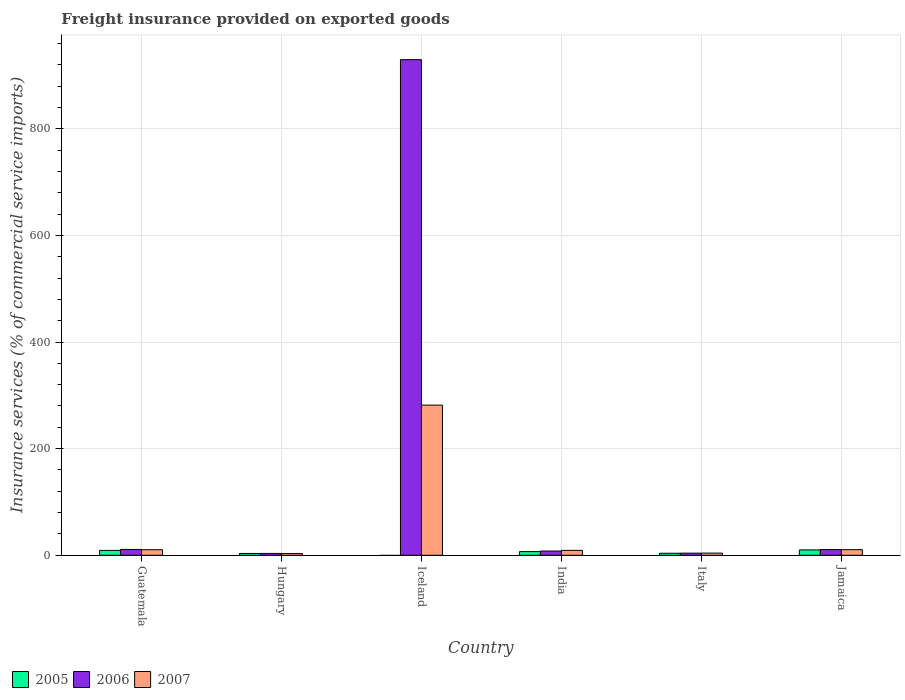How many different coloured bars are there?
Provide a short and direct response. 3. How many groups of bars are there?
Offer a very short reply. 6. What is the label of the 1st group of bars from the left?
Offer a terse response. Guatemala. What is the freight insurance provided on exported goods in 2005 in Jamaica?
Offer a very short reply. 10.03. Across all countries, what is the maximum freight insurance provided on exported goods in 2005?
Your answer should be very brief. 10.03. Across all countries, what is the minimum freight insurance provided on exported goods in 2007?
Offer a terse response. 3.16. In which country was the freight insurance provided on exported goods in 2005 maximum?
Make the answer very short. Jamaica. What is the total freight insurance provided on exported goods in 2007 in the graph?
Offer a terse response. 319.09. What is the difference between the freight insurance provided on exported goods in 2006 in Iceland and that in India?
Provide a short and direct response. 921.63. What is the difference between the freight insurance provided on exported goods in 2007 in Guatemala and the freight insurance provided on exported goods in 2005 in Hungary?
Offer a very short reply. 7. What is the average freight insurance provided on exported goods in 2007 per country?
Keep it short and to the point. 53.18. What is the difference between the freight insurance provided on exported goods of/in 2006 and freight insurance provided on exported goods of/in 2007 in Jamaica?
Offer a very short reply. 0.15. In how many countries, is the freight insurance provided on exported goods in 2007 greater than 440 %?
Provide a succinct answer. 0. What is the ratio of the freight insurance provided on exported goods in 2007 in Guatemala to that in Italy?
Your response must be concise. 2.56. Is the freight insurance provided on exported goods in 2007 in Hungary less than that in Jamaica?
Your response must be concise. Yes. What is the difference between the highest and the second highest freight insurance provided on exported goods in 2006?
Offer a terse response. 918.68. What is the difference between the highest and the lowest freight insurance provided on exported goods in 2005?
Offer a very short reply. 10.03. In how many countries, is the freight insurance provided on exported goods in 2006 greater than the average freight insurance provided on exported goods in 2006 taken over all countries?
Offer a very short reply. 1. Is the sum of the freight insurance provided on exported goods in 2007 in India and Jamaica greater than the maximum freight insurance provided on exported goods in 2006 across all countries?
Offer a terse response. No. Are all the bars in the graph horizontal?
Make the answer very short. No. What is the difference between two consecutive major ticks on the Y-axis?
Offer a very short reply. 200. Are the values on the major ticks of Y-axis written in scientific E-notation?
Ensure brevity in your answer.  No. Does the graph contain any zero values?
Your answer should be compact. Yes. Where does the legend appear in the graph?
Offer a very short reply. Bottom left. How many legend labels are there?
Provide a succinct answer. 3. What is the title of the graph?
Give a very brief answer. Freight insurance provided on exported goods. What is the label or title of the Y-axis?
Ensure brevity in your answer.  Insurance services (% of commercial service imports). What is the Insurance services (% of commercial service imports) in 2005 in Guatemala?
Provide a succinct answer. 9.14. What is the Insurance services (% of commercial service imports) in 2006 in Guatemala?
Your answer should be very brief. 10.92. What is the Insurance services (% of commercial service imports) of 2007 in Guatemala?
Keep it short and to the point. 10.41. What is the Insurance services (% of commercial service imports) of 2005 in Hungary?
Ensure brevity in your answer.  3.41. What is the Insurance services (% of commercial service imports) in 2006 in Hungary?
Make the answer very short. 3.46. What is the Insurance services (% of commercial service imports) in 2007 in Hungary?
Ensure brevity in your answer.  3.16. What is the Insurance services (% of commercial service imports) of 2005 in Iceland?
Your response must be concise. 0. What is the Insurance services (% of commercial service imports) in 2006 in Iceland?
Provide a short and direct response. 929.6. What is the Insurance services (% of commercial service imports) in 2007 in Iceland?
Offer a very short reply. 281.68. What is the Insurance services (% of commercial service imports) of 2005 in India?
Ensure brevity in your answer.  6.85. What is the Insurance services (% of commercial service imports) in 2006 in India?
Give a very brief answer. 7.96. What is the Insurance services (% of commercial service imports) of 2007 in India?
Give a very brief answer. 9.21. What is the Insurance services (% of commercial service imports) of 2005 in Italy?
Offer a very short reply. 3.79. What is the Insurance services (% of commercial service imports) in 2006 in Italy?
Your answer should be compact. 3.97. What is the Insurance services (% of commercial service imports) of 2007 in Italy?
Make the answer very short. 4.07. What is the Insurance services (% of commercial service imports) in 2005 in Jamaica?
Offer a very short reply. 10.03. What is the Insurance services (% of commercial service imports) in 2006 in Jamaica?
Provide a short and direct response. 10.71. What is the Insurance services (% of commercial service imports) in 2007 in Jamaica?
Offer a terse response. 10.56. Across all countries, what is the maximum Insurance services (% of commercial service imports) in 2005?
Your response must be concise. 10.03. Across all countries, what is the maximum Insurance services (% of commercial service imports) in 2006?
Ensure brevity in your answer.  929.6. Across all countries, what is the maximum Insurance services (% of commercial service imports) of 2007?
Your answer should be compact. 281.68. Across all countries, what is the minimum Insurance services (% of commercial service imports) in 2005?
Make the answer very short. 0. Across all countries, what is the minimum Insurance services (% of commercial service imports) in 2006?
Provide a succinct answer. 3.46. Across all countries, what is the minimum Insurance services (% of commercial service imports) of 2007?
Your response must be concise. 3.16. What is the total Insurance services (% of commercial service imports) in 2005 in the graph?
Provide a succinct answer. 33.22. What is the total Insurance services (% of commercial service imports) of 2006 in the graph?
Your response must be concise. 966.62. What is the total Insurance services (% of commercial service imports) in 2007 in the graph?
Give a very brief answer. 319.09. What is the difference between the Insurance services (% of commercial service imports) of 2005 in Guatemala and that in Hungary?
Your response must be concise. 5.73. What is the difference between the Insurance services (% of commercial service imports) of 2006 in Guatemala and that in Hungary?
Offer a terse response. 7.46. What is the difference between the Insurance services (% of commercial service imports) in 2007 in Guatemala and that in Hungary?
Give a very brief answer. 7.25. What is the difference between the Insurance services (% of commercial service imports) in 2006 in Guatemala and that in Iceland?
Provide a short and direct response. -918.68. What is the difference between the Insurance services (% of commercial service imports) in 2007 in Guatemala and that in Iceland?
Offer a very short reply. -271.27. What is the difference between the Insurance services (% of commercial service imports) of 2005 in Guatemala and that in India?
Your answer should be compact. 2.29. What is the difference between the Insurance services (% of commercial service imports) in 2006 in Guatemala and that in India?
Offer a very short reply. 2.96. What is the difference between the Insurance services (% of commercial service imports) in 2007 in Guatemala and that in India?
Give a very brief answer. 1.2. What is the difference between the Insurance services (% of commercial service imports) in 2005 in Guatemala and that in Italy?
Keep it short and to the point. 5.35. What is the difference between the Insurance services (% of commercial service imports) in 2006 in Guatemala and that in Italy?
Offer a terse response. 6.95. What is the difference between the Insurance services (% of commercial service imports) of 2007 in Guatemala and that in Italy?
Ensure brevity in your answer.  6.34. What is the difference between the Insurance services (% of commercial service imports) of 2005 in Guatemala and that in Jamaica?
Make the answer very short. -0.89. What is the difference between the Insurance services (% of commercial service imports) in 2006 in Guatemala and that in Jamaica?
Your answer should be compact. 0.21. What is the difference between the Insurance services (% of commercial service imports) of 2007 in Guatemala and that in Jamaica?
Provide a succinct answer. -0.15. What is the difference between the Insurance services (% of commercial service imports) of 2006 in Hungary and that in Iceland?
Provide a short and direct response. -926.14. What is the difference between the Insurance services (% of commercial service imports) in 2007 in Hungary and that in Iceland?
Keep it short and to the point. -278.52. What is the difference between the Insurance services (% of commercial service imports) in 2005 in Hungary and that in India?
Ensure brevity in your answer.  -3.44. What is the difference between the Insurance services (% of commercial service imports) in 2006 in Hungary and that in India?
Make the answer very short. -4.5. What is the difference between the Insurance services (% of commercial service imports) of 2007 in Hungary and that in India?
Ensure brevity in your answer.  -6.05. What is the difference between the Insurance services (% of commercial service imports) of 2005 in Hungary and that in Italy?
Your answer should be very brief. -0.37. What is the difference between the Insurance services (% of commercial service imports) in 2006 in Hungary and that in Italy?
Your response must be concise. -0.51. What is the difference between the Insurance services (% of commercial service imports) of 2007 in Hungary and that in Italy?
Your answer should be very brief. -0.92. What is the difference between the Insurance services (% of commercial service imports) in 2005 in Hungary and that in Jamaica?
Make the answer very short. -6.61. What is the difference between the Insurance services (% of commercial service imports) in 2006 in Hungary and that in Jamaica?
Ensure brevity in your answer.  -7.25. What is the difference between the Insurance services (% of commercial service imports) in 2007 in Hungary and that in Jamaica?
Your response must be concise. -7.4. What is the difference between the Insurance services (% of commercial service imports) in 2006 in Iceland and that in India?
Provide a succinct answer. 921.63. What is the difference between the Insurance services (% of commercial service imports) of 2007 in Iceland and that in India?
Keep it short and to the point. 272.46. What is the difference between the Insurance services (% of commercial service imports) of 2006 in Iceland and that in Italy?
Offer a very short reply. 925.62. What is the difference between the Insurance services (% of commercial service imports) in 2007 in Iceland and that in Italy?
Offer a very short reply. 277.6. What is the difference between the Insurance services (% of commercial service imports) in 2006 in Iceland and that in Jamaica?
Give a very brief answer. 918.89. What is the difference between the Insurance services (% of commercial service imports) of 2007 in Iceland and that in Jamaica?
Ensure brevity in your answer.  271.12. What is the difference between the Insurance services (% of commercial service imports) of 2005 in India and that in Italy?
Your response must be concise. 3.06. What is the difference between the Insurance services (% of commercial service imports) in 2006 in India and that in Italy?
Your answer should be very brief. 3.99. What is the difference between the Insurance services (% of commercial service imports) of 2007 in India and that in Italy?
Your response must be concise. 5.14. What is the difference between the Insurance services (% of commercial service imports) of 2005 in India and that in Jamaica?
Keep it short and to the point. -3.18. What is the difference between the Insurance services (% of commercial service imports) in 2006 in India and that in Jamaica?
Offer a terse response. -2.75. What is the difference between the Insurance services (% of commercial service imports) of 2007 in India and that in Jamaica?
Give a very brief answer. -1.35. What is the difference between the Insurance services (% of commercial service imports) in 2005 in Italy and that in Jamaica?
Your response must be concise. -6.24. What is the difference between the Insurance services (% of commercial service imports) of 2006 in Italy and that in Jamaica?
Ensure brevity in your answer.  -6.74. What is the difference between the Insurance services (% of commercial service imports) of 2007 in Italy and that in Jamaica?
Your response must be concise. -6.49. What is the difference between the Insurance services (% of commercial service imports) of 2005 in Guatemala and the Insurance services (% of commercial service imports) of 2006 in Hungary?
Make the answer very short. 5.68. What is the difference between the Insurance services (% of commercial service imports) of 2005 in Guatemala and the Insurance services (% of commercial service imports) of 2007 in Hungary?
Provide a short and direct response. 5.98. What is the difference between the Insurance services (% of commercial service imports) of 2006 in Guatemala and the Insurance services (% of commercial service imports) of 2007 in Hungary?
Your response must be concise. 7.76. What is the difference between the Insurance services (% of commercial service imports) of 2005 in Guatemala and the Insurance services (% of commercial service imports) of 2006 in Iceland?
Your answer should be compact. -920.46. What is the difference between the Insurance services (% of commercial service imports) of 2005 in Guatemala and the Insurance services (% of commercial service imports) of 2007 in Iceland?
Provide a succinct answer. -272.54. What is the difference between the Insurance services (% of commercial service imports) of 2006 in Guatemala and the Insurance services (% of commercial service imports) of 2007 in Iceland?
Give a very brief answer. -270.76. What is the difference between the Insurance services (% of commercial service imports) in 2005 in Guatemala and the Insurance services (% of commercial service imports) in 2006 in India?
Offer a terse response. 1.18. What is the difference between the Insurance services (% of commercial service imports) of 2005 in Guatemala and the Insurance services (% of commercial service imports) of 2007 in India?
Your answer should be compact. -0.07. What is the difference between the Insurance services (% of commercial service imports) in 2006 in Guatemala and the Insurance services (% of commercial service imports) in 2007 in India?
Make the answer very short. 1.71. What is the difference between the Insurance services (% of commercial service imports) in 2005 in Guatemala and the Insurance services (% of commercial service imports) in 2006 in Italy?
Make the answer very short. 5.17. What is the difference between the Insurance services (% of commercial service imports) in 2005 in Guatemala and the Insurance services (% of commercial service imports) in 2007 in Italy?
Offer a terse response. 5.07. What is the difference between the Insurance services (% of commercial service imports) in 2006 in Guatemala and the Insurance services (% of commercial service imports) in 2007 in Italy?
Make the answer very short. 6.85. What is the difference between the Insurance services (% of commercial service imports) of 2005 in Guatemala and the Insurance services (% of commercial service imports) of 2006 in Jamaica?
Provide a succinct answer. -1.57. What is the difference between the Insurance services (% of commercial service imports) of 2005 in Guatemala and the Insurance services (% of commercial service imports) of 2007 in Jamaica?
Offer a very short reply. -1.42. What is the difference between the Insurance services (% of commercial service imports) in 2006 in Guatemala and the Insurance services (% of commercial service imports) in 2007 in Jamaica?
Your response must be concise. 0.36. What is the difference between the Insurance services (% of commercial service imports) in 2005 in Hungary and the Insurance services (% of commercial service imports) in 2006 in Iceland?
Provide a succinct answer. -926.18. What is the difference between the Insurance services (% of commercial service imports) in 2005 in Hungary and the Insurance services (% of commercial service imports) in 2007 in Iceland?
Ensure brevity in your answer.  -278.26. What is the difference between the Insurance services (% of commercial service imports) in 2006 in Hungary and the Insurance services (% of commercial service imports) in 2007 in Iceland?
Ensure brevity in your answer.  -278.22. What is the difference between the Insurance services (% of commercial service imports) of 2005 in Hungary and the Insurance services (% of commercial service imports) of 2006 in India?
Offer a very short reply. -4.55. What is the difference between the Insurance services (% of commercial service imports) in 2005 in Hungary and the Insurance services (% of commercial service imports) in 2007 in India?
Ensure brevity in your answer.  -5.8. What is the difference between the Insurance services (% of commercial service imports) in 2006 in Hungary and the Insurance services (% of commercial service imports) in 2007 in India?
Offer a very short reply. -5.75. What is the difference between the Insurance services (% of commercial service imports) of 2005 in Hungary and the Insurance services (% of commercial service imports) of 2006 in Italy?
Give a very brief answer. -0.56. What is the difference between the Insurance services (% of commercial service imports) of 2005 in Hungary and the Insurance services (% of commercial service imports) of 2007 in Italy?
Offer a very short reply. -0.66. What is the difference between the Insurance services (% of commercial service imports) of 2006 in Hungary and the Insurance services (% of commercial service imports) of 2007 in Italy?
Your response must be concise. -0.61. What is the difference between the Insurance services (% of commercial service imports) of 2005 in Hungary and the Insurance services (% of commercial service imports) of 2006 in Jamaica?
Keep it short and to the point. -7.3. What is the difference between the Insurance services (% of commercial service imports) of 2005 in Hungary and the Insurance services (% of commercial service imports) of 2007 in Jamaica?
Provide a succinct answer. -7.15. What is the difference between the Insurance services (% of commercial service imports) of 2006 in Hungary and the Insurance services (% of commercial service imports) of 2007 in Jamaica?
Give a very brief answer. -7.1. What is the difference between the Insurance services (% of commercial service imports) of 2006 in Iceland and the Insurance services (% of commercial service imports) of 2007 in India?
Keep it short and to the point. 920.38. What is the difference between the Insurance services (% of commercial service imports) in 2006 in Iceland and the Insurance services (% of commercial service imports) in 2007 in Italy?
Provide a short and direct response. 925.52. What is the difference between the Insurance services (% of commercial service imports) of 2006 in Iceland and the Insurance services (% of commercial service imports) of 2007 in Jamaica?
Your answer should be compact. 919.04. What is the difference between the Insurance services (% of commercial service imports) in 2005 in India and the Insurance services (% of commercial service imports) in 2006 in Italy?
Make the answer very short. 2.88. What is the difference between the Insurance services (% of commercial service imports) in 2005 in India and the Insurance services (% of commercial service imports) in 2007 in Italy?
Offer a terse response. 2.78. What is the difference between the Insurance services (% of commercial service imports) in 2006 in India and the Insurance services (% of commercial service imports) in 2007 in Italy?
Keep it short and to the point. 3.89. What is the difference between the Insurance services (% of commercial service imports) of 2005 in India and the Insurance services (% of commercial service imports) of 2006 in Jamaica?
Make the answer very short. -3.86. What is the difference between the Insurance services (% of commercial service imports) of 2005 in India and the Insurance services (% of commercial service imports) of 2007 in Jamaica?
Keep it short and to the point. -3.71. What is the difference between the Insurance services (% of commercial service imports) in 2006 in India and the Insurance services (% of commercial service imports) in 2007 in Jamaica?
Your response must be concise. -2.6. What is the difference between the Insurance services (% of commercial service imports) in 2005 in Italy and the Insurance services (% of commercial service imports) in 2006 in Jamaica?
Offer a very short reply. -6.92. What is the difference between the Insurance services (% of commercial service imports) of 2005 in Italy and the Insurance services (% of commercial service imports) of 2007 in Jamaica?
Make the answer very short. -6.77. What is the difference between the Insurance services (% of commercial service imports) of 2006 in Italy and the Insurance services (% of commercial service imports) of 2007 in Jamaica?
Offer a terse response. -6.59. What is the average Insurance services (% of commercial service imports) of 2005 per country?
Your response must be concise. 5.54. What is the average Insurance services (% of commercial service imports) in 2006 per country?
Offer a very short reply. 161.1. What is the average Insurance services (% of commercial service imports) in 2007 per country?
Provide a short and direct response. 53.18. What is the difference between the Insurance services (% of commercial service imports) of 2005 and Insurance services (% of commercial service imports) of 2006 in Guatemala?
Your response must be concise. -1.78. What is the difference between the Insurance services (% of commercial service imports) of 2005 and Insurance services (% of commercial service imports) of 2007 in Guatemala?
Give a very brief answer. -1.27. What is the difference between the Insurance services (% of commercial service imports) of 2006 and Insurance services (% of commercial service imports) of 2007 in Guatemala?
Offer a very short reply. 0.51. What is the difference between the Insurance services (% of commercial service imports) in 2005 and Insurance services (% of commercial service imports) in 2006 in Hungary?
Keep it short and to the point. -0.05. What is the difference between the Insurance services (% of commercial service imports) of 2005 and Insurance services (% of commercial service imports) of 2007 in Hungary?
Your answer should be very brief. 0.26. What is the difference between the Insurance services (% of commercial service imports) of 2006 and Insurance services (% of commercial service imports) of 2007 in Hungary?
Ensure brevity in your answer.  0.3. What is the difference between the Insurance services (% of commercial service imports) in 2006 and Insurance services (% of commercial service imports) in 2007 in Iceland?
Offer a very short reply. 647.92. What is the difference between the Insurance services (% of commercial service imports) of 2005 and Insurance services (% of commercial service imports) of 2006 in India?
Provide a succinct answer. -1.11. What is the difference between the Insurance services (% of commercial service imports) in 2005 and Insurance services (% of commercial service imports) in 2007 in India?
Provide a succinct answer. -2.36. What is the difference between the Insurance services (% of commercial service imports) in 2006 and Insurance services (% of commercial service imports) in 2007 in India?
Your answer should be compact. -1.25. What is the difference between the Insurance services (% of commercial service imports) in 2005 and Insurance services (% of commercial service imports) in 2006 in Italy?
Give a very brief answer. -0.19. What is the difference between the Insurance services (% of commercial service imports) of 2005 and Insurance services (% of commercial service imports) of 2007 in Italy?
Ensure brevity in your answer.  -0.29. What is the difference between the Insurance services (% of commercial service imports) of 2006 and Insurance services (% of commercial service imports) of 2007 in Italy?
Your answer should be compact. -0.1. What is the difference between the Insurance services (% of commercial service imports) in 2005 and Insurance services (% of commercial service imports) in 2006 in Jamaica?
Your answer should be compact. -0.68. What is the difference between the Insurance services (% of commercial service imports) in 2005 and Insurance services (% of commercial service imports) in 2007 in Jamaica?
Make the answer very short. -0.53. What is the difference between the Insurance services (% of commercial service imports) in 2006 and Insurance services (% of commercial service imports) in 2007 in Jamaica?
Your answer should be very brief. 0.15. What is the ratio of the Insurance services (% of commercial service imports) of 2005 in Guatemala to that in Hungary?
Your answer should be compact. 2.68. What is the ratio of the Insurance services (% of commercial service imports) in 2006 in Guatemala to that in Hungary?
Provide a succinct answer. 3.16. What is the ratio of the Insurance services (% of commercial service imports) of 2007 in Guatemala to that in Hungary?
Keep it short and to the point. 3.3. What is the ratio of the Insurance services (% of commercial service imports) of 2006 in Guatemala to that in Iceland?
Provide a succinct answer. 0.01. What is the ratio of the Insurance services (% of commercial service imports) in 2007 in Guatemala to that in Iceland?
Offer a very short reply. 0.04. What is the ratio of the Insurance services (% of commercial service imports) in 2005 in Guatemala to that in India?
Give a very brief answer. 1.33. What is the ratio of the Insurance services (% of commercial service imports) in 2006 in Guatemala to that in India?
Keep it short and to the point. 1.37. What is the ratio of the Insurance services (% of commercial service imports) in 2007 in Guatemala to that in India?
Provide a short and direct response. 1.13. What is the ratio of the Insurance services (% of commercial service imports) in 2005 in Guatemala to that in Italy?
Provide a short and direct response. 2.41. What is the ratio of the Insurance services (% of commercial service imports) of 2006 in Guatemala to that in Italy?
Offer a terse response. 2.75. What is the ratio of the Insurance services (% of commercial service imports) in 2007 in Guatemala to that in Italy?
Your answer should be compact. 2.56. What is the ratio of the Insurance services (% of commercial service imports) in 2005 in Guatemala to that in Jamaica?
Your answer should be very brief. 0.91. What is the ratio of the Insurance services (% of commercial service imports) in 2006 in Guatemala to that in Jamaica?
Offer a very short reply. 1.02. What is the ratio of the Insurance services (% of commercial service imports) in 2007 in Guatemala to that in Jamaica?
Give a very brief answer. 0.99. What is the ratio of the Insurance services (% of commercial service imports) of 2006 in Hungary to that in Iceland?
Make the answer very short. 0. What is the ratio of the Insurance services (% of commercial service imports) in 2007 in Hungary to that in Iceland?
Your answer should be compact. 0.01. What is the ratio of the Insurance services (% of commercial service imports) in 2005 in Hungary to that in India?
Give a very brief answer. 0.5. What is the ratio of the Insurance services (% of commercial service imports) in 2006 in Hungary to that in India?
Make the answer very short. 0.43. What is the ratio of the Insurance services (% of commercial service imports) in 2007 in Hungary to that in India?
Your answer should be compact. 0.34. What is the ratio of the Insurance services (% of commercial service imports) in 2005 in Hungary to that in Italy?
Offer a terse response. 0.9. What is the ratio of the Insurance services (% of commercial service imports) in 2006 in Hungary to that in Italy?
Give a very brief answer. 0.87. What is the ratio of the Insurance services (% of commercial service imports) of 2007 in Hungary to that in Italy?
Your response must be concise. 0.78. What is the ratio of the Insurance services (% of commercial service imports) of 2005 in Hungary to that in Jamaica?
Ensure brevity in your answer.  0.34. What is the ratio of the Insurance services (% of commercial service imports) of 2006 in Hungary to that in Jamaica?
Keep it short and to the point. 0.32. What is the ratio of the Insurance services (% of commercial service imports) in 2007 in Hungary to that in Jamaica?
Your answer should be very brief. 0.3. What is the ratio of the Insurance services (% of commercial service imports) in 2006 in Iceland to that in India?
Make the answer very short. 116.76. What is the ratio of the Insurance services (% of commercial service imports) in 2007 in Iceland to that in India?
Provide a succinct answer. 30.58. What is the ratio of the Insurance services (% of commercial service imports) of 2006 in Iceland to that in Italy?
Your answer should be very brief. 233.89. What is the ratio of the Insurance services (% of commercial service imports) in 2007 in Iceland to that in Italy?
Provide a succinct answer. 69.15. What is the ratio of the Insurance services (% of commercial service imports) of 2006 in Iceland to that in Jamaica?
Provide a short and direct response. 86.79. What is the ratio of the Insurance services (% of commercial service imports) of 2007 in Iceland to that in Jamaica?
Offer a terse response. 26.67. What is the ratio of the Insurance services (% of commercial service imports) in 2005 in India to that in Italy?
Make the answer very short. 1.81. What is the ratio of the Insurance services (% of commercial service imports) of 2006 in India to that in Italy?
Provide a succinct answer. 2. What is the ratio of the Insurance services (% of commercial service imports) of 2007 in India to that in Italy?
Your answer should be compact. 2.26. What is the ratio of the Insurance services (% of commercial service imports) in 2005 in India to that in Jamaica?
Offer a very short reply. 0.68. What is the ratio of the Insurance services (% of commercial service imports) of 2006 in India to that in Jamaica?
Your answer should be compact. 0.74. What is the ratio of the Insurance services (% of commercial service imports) of 2007 in India to that in Jamaica?
Make the answer very short. 0.87. What is the ratio of the Insurance services (% of commercial service imports) in 2005 in Italy to that in Jamaica?
Give a very brief answer. 0.38. What is the ratio of the Insurance services (% of commercial service imports) of 2006 in Italy to that in Jamaica?
Your response must be concise. 0.37. What is the ratio of the Insurance services (% of commercial service imports) in 2007 in Italy to that in Jamaica?
Make the answer very short. 0.39. What is the difference between the highest and the second highest Insurance services (% of commercial service imports) of 2005?
Provide a succinct answer. 0.89. What is the difference between the highest and the second highest Insurance services (% of commercial service imports) in 2006?
Your answer should be compact. 918.68. What is the difference between the highest and the second highest Insurance services (% of commercial service imports) of 2007?
Keep it short and to the point. 271.12. What is the difference between the highest and the lowest Insurance services (% of commercial service imports) of 2005?
Provide a succinct answer. 10.03. What is the difference between the highest and the lowest Insurance services (% of commercial service imports) of 2006?
Give a very brief answer. 926.14. What is the difference between the highest and the lowest Insurance services (% of commercial service imports) of 2007?
Your response must be concise. 278.52. 